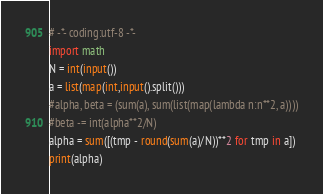<code> <loc_0><loc_0><loc_500><loc_500><_Python_># -*- coding:utf-8 -*-
import math
N = int(input())
a = list(map(int,input().split()))
#alpha, beta = (sum(a), sum(list(map(lambda n:n**2, a))))
#beta -= int(alpha**2/N)
alpha = sum([(tmp - round(sum(a)/N))**2 for tmp in a]) 
print(alpha)</code> 